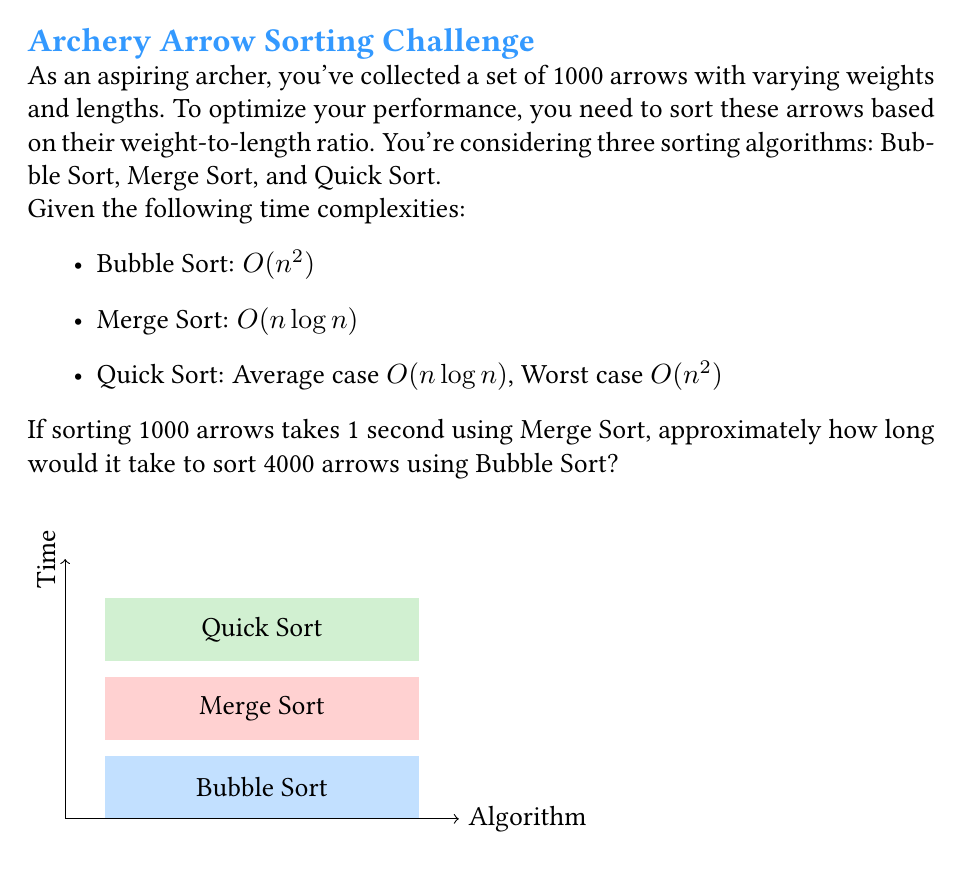Solve this math problem. Let's approach this step-by-step:

1) First, we need to understand the relationship between input size and time for Merge Sort:
   - For 1000 arrows, Merge Sort takes 1 second
   - Merge Sort has a time complexity of $O(n \log n)$

2) Let's express this mathematically:
   $1000 \log 1000 = k$, where $k$ is some constant

3) Now, for 4000 arrows with Merge Sort:
   Time = $\frac{4000 \log 4000}{1000 \log 1000} = 4 \cdot \frac{\log 4000}{\log 1000} \approx 5.3$ seconds

4) However, we need to find the time for Bubble Sort. Bubble Sort has a time complexity of $O(n^2)$.

5) Let's compare the time complexities:
   - For Merge Sort: $T_{MS}(n) = n \log n$
   - For Bubble Sort: $T_{BS}(n) = n^2$

6) The ratio of these for 4000 arrows:
   $\frac{T_{BS}(4000)}{T_{MS}(4000)} = \frac{4000^2}{4000 \log 4000} = \frac{4000}{\log 4000} \approx 331.75$

7) Therefore, Bubble Sort will take approximately 331.75 times longer than Merge Sort for 4000 arrows.

8) Since Merge Sort takes about 5.3 seconds for 4000 arrows, Bubble Sort will take:
   $5.3 \cdot 331.75 \approx 1758$ seconds
Answer: $\approx 1758$ seconds 